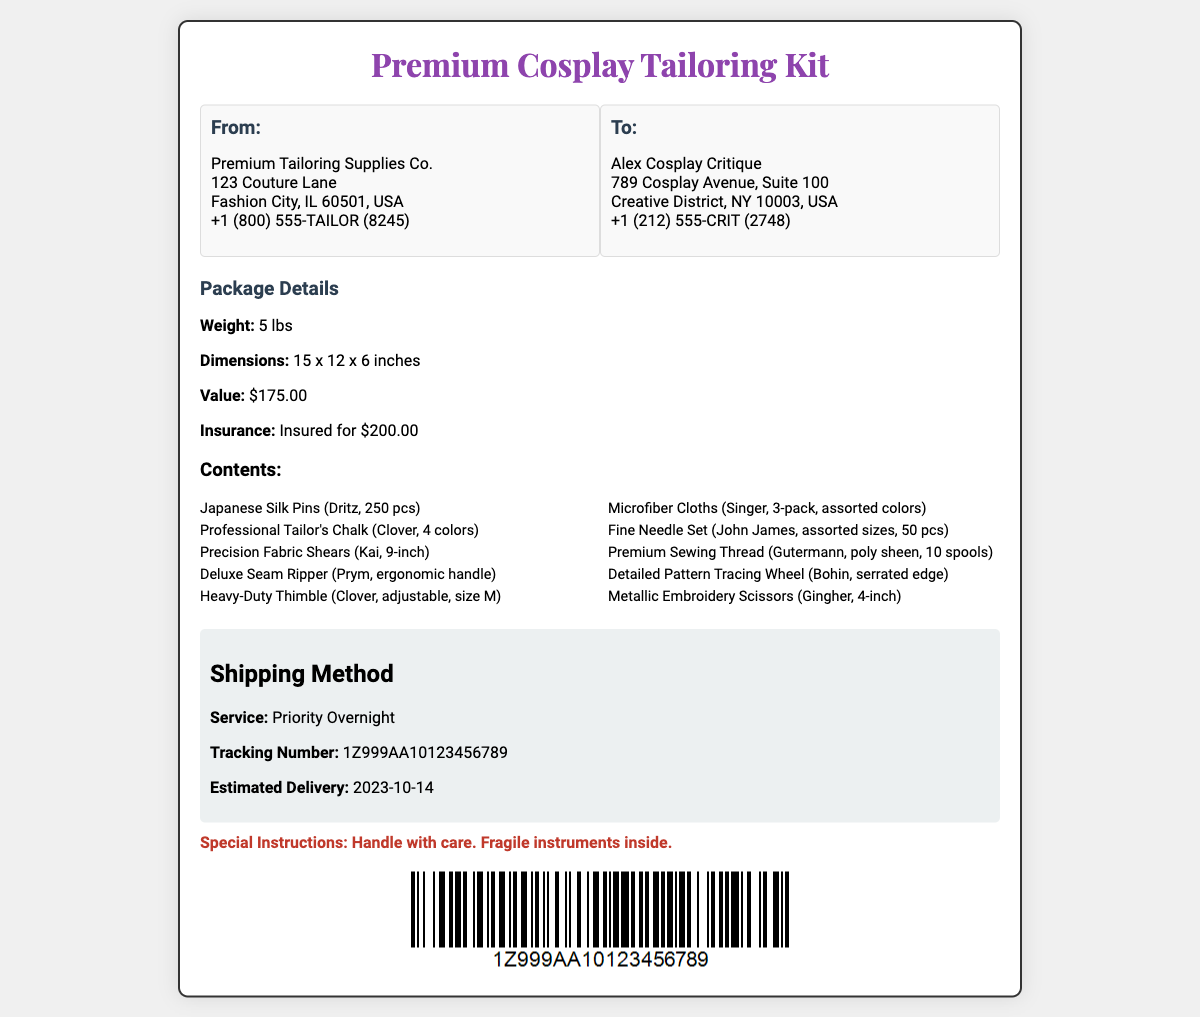What is the weight of the package? The weight of the package is explicitly stated in the document as 5 lbs.
Answer: 5 lbs Who is the sender of the package? The sender's information is listed under "From," identifying the company as Premium Tailoring Supplies Co.
Answer: Premium Tailoring Supplies Co What is the value of the tailoring kit? The value is mentioned in the document as $175.00.
Answer: $175.00 What is the estimated delivery date? The estimated delivery date is clearly given as 2023-10-14.
Answer: 2023-10-14 What type of shipping service is used? The shipping method section specifies that the service used is Priority Overnight.
Answer: Priority Overnight How many pieces of Japanese Silk Pins are included? The contents list states that there are 250 pcs of Japanese Silk Pins.
Answer: 250 pcs What is the insurance value of the package? The insurance value for the package is provided as $200.00.
Answer: $200.00 What are the dimensions of the package? The document includes the dimensions of the package as 15 x 12 x 6 inches.
Answer: 15 x 12 x 6 inches What special instructions are provided for shipping? The special instructions state to "Handle with care. Fragile instruments inside."
Answer: Handle with care. Fragile instruments inside 